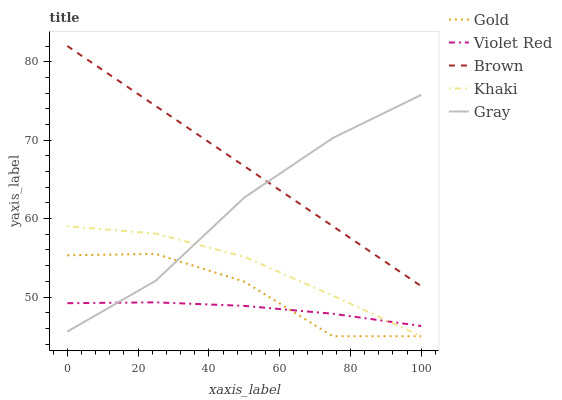Does Violet Red have the minimum area under the curve?
Answer yes or no. Yes. Does Brown have the maximum area under the curve?
Answer yes or no. Yes. Does Khaki have the minimum area under the curve?
Answer yes or no. No. Does Khaki have the maximum area under the curve?
Answer yes or no. No. Is Brown the smoothest?
Answer yes or no. Yes. Is Gold the roughest?
Answer yes or no. Yes. Is Violet Red the smoothest?
Answer yes or no. No. Is Violet Red the roughest?
Answer yes or no. No. Does Khaki have the lowest value?
Answer yes or no. Yes. Does Violet Red have the lowest value?
Answer yes or no. No. Does Brown have the highest value?
Answer yes or no. Yes. Does Khaki have the highest value?
Answer yes or no. No. Is Gold less than Brown?
Answer yes or no. Yes. Is Brown greater than Gold?
Answer yes or no. Yes. Does Brown intersect Gray?
Answer yes or no. Yes. Is Brown less than Gray?
Answer yes or no. No. Is Brown greater than Gray?
Answer yes or no. No. Does Gold intersect Brown?
Answer yes or no. No. 